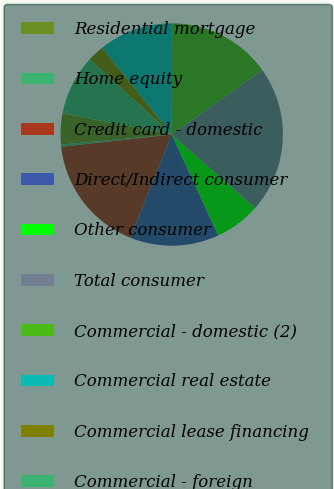<chart> <loc_0><loc_0><loc_500><loc_500><pie_chart><fcel>Residential mortgage<fcel>Home equity<fcel>Credit card - domestic<fcel>Direct/Indirect consumer<fcel>Other consumer<fcel>Total consumer<fcel>Commercial - domestic (2)<fcel>Commercial real estate<fcel>Commercial lease financing<fcel>Commercial - foreign<nl><fcel>4.53%<fcel>0.32%<fcel>17.16%<fcel>12.95%<fcel>6.63%<fcel>21.37%<fcel>15.05%<fcel>10.84%<fcel>2.42%<fcel>8.74%<nl></chart> 